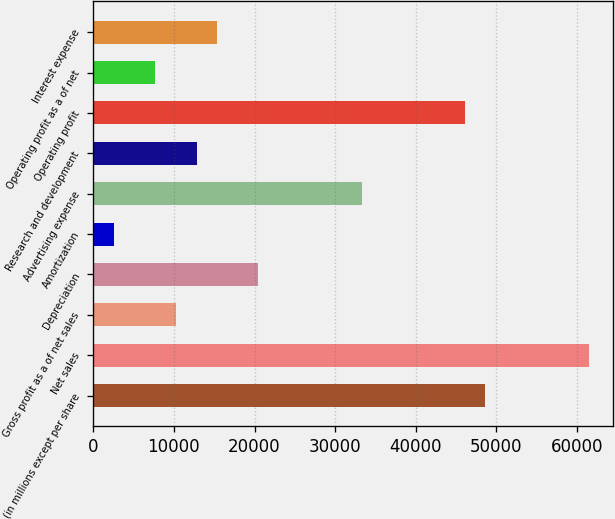Convert chart to OTSL. <chart><loc_0><loc_0><loc_500><loc_500><bar_chart><fcel>(in millions except per share<fcel>Net sales<fcel>Gross profit as a of net sales<fcel>Depreciation<fcel>Amortization<fcel>Advertising expense<fcel>Research and development<fcel>Operating profit<fcel>Operating profit as a of net<fcel>Interest expense<nl><fcel>48650.4<fcel>61452.8<fcel>10243<fcel>20485<fcel>2561.55<fcel>33287.4<fcel>12803.5<fcel>46089.9<fcel>7682.53<fcel>15364<nl></chart> 